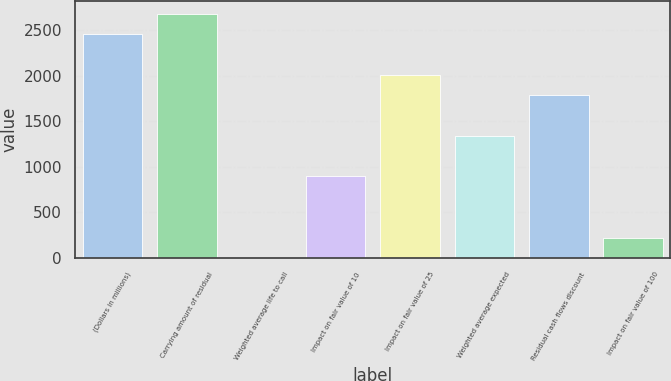<chart> <loc_0><loc_0><loc_500><loc_500><bar_chart><fcel>(Dollars in millions)<fcel>Carrying amount of residual<fcel>Weighted average life to call<fcel>Impact on fair value of 10<fcel>Impact on fair value of 25<fcel>Weighted average expected<fcel>Residual cash flows discount<fcel>Impact on fair value of 100<nl><fcel>2456.27<fcel>2679.54<fcel>0.3<fcel>893.38<fcel>2009.73<fcel>1339.92<fcel>1786.46<fcel>223.57<nl></chart> 